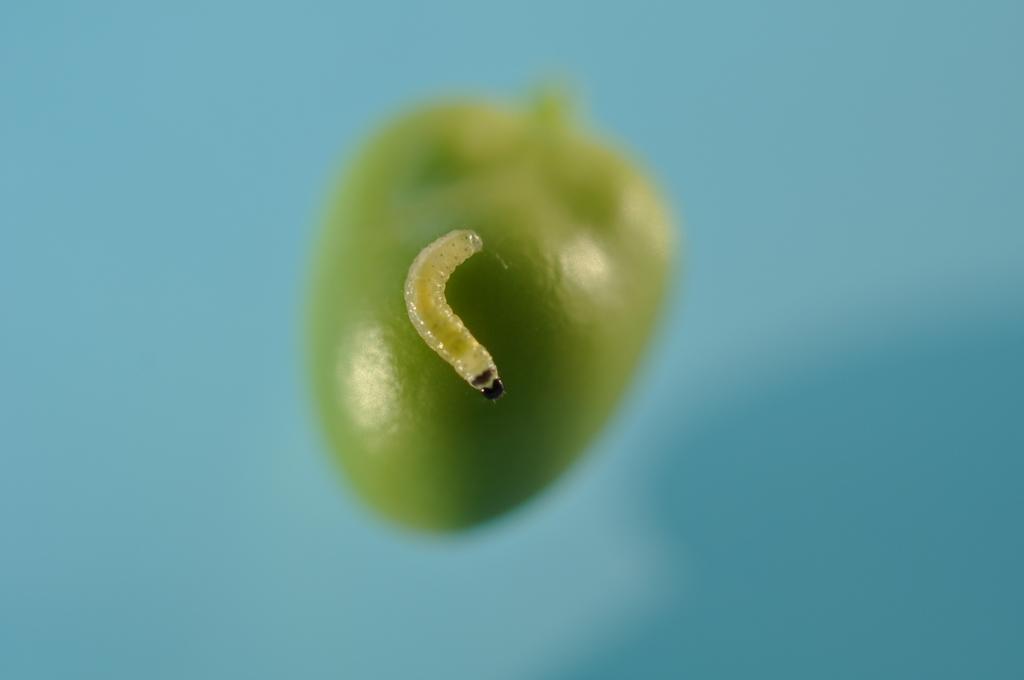Describe this image in one or two sentences. In the foreground of this image, there is a worm on a green object and the background image is blurred. 